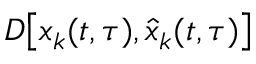<formula> <loc_0><loc_0><loc_500><loc_500>D \left [ x _ { k } ( t , \tau ) , \hat { x } _ { k } ( t , \tau ) \right ]</formula> 